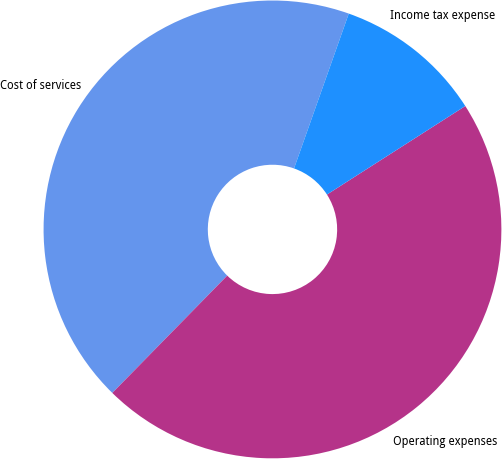Convert chart to OTSL. <chart><loc_0><loc_0><loc_500><loc_500><pie_chart><fcel>Cost of services<fcel>Operating expenses<fcel>Income tax expense<nl><fcel>43.07%<fcel>46.39%<fcel>10.53%<nl></chart> 